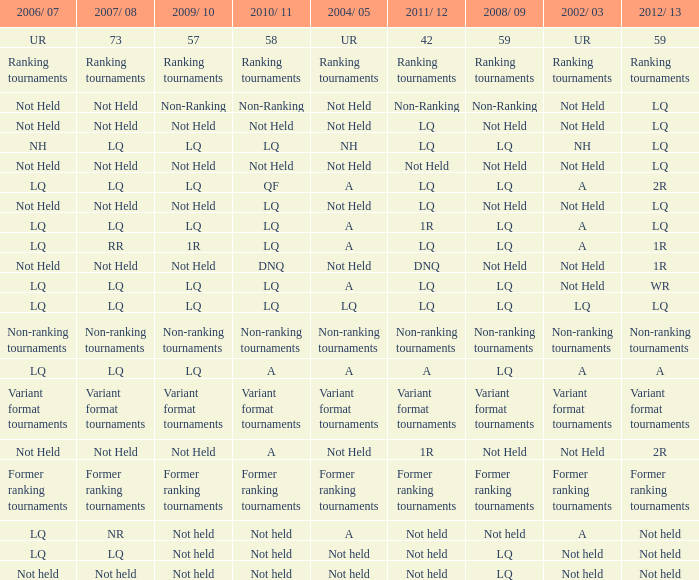Name the 2009/10 with 2011/12 of lq and 2008/09 of not held Not Held, Not Held. 